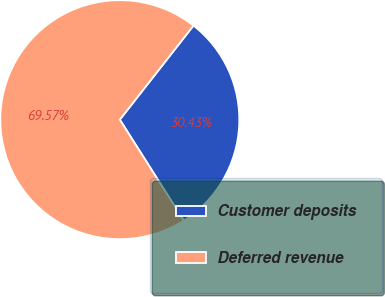Convert chart to OTSL. <chart><loc_0><loc_0><loc_500><loc_500><pie_chart><fcel>Customer deposits<fcel>Deferred revenue<nl><fcel>30.43%<fcel>69.57%<nl></chart> 